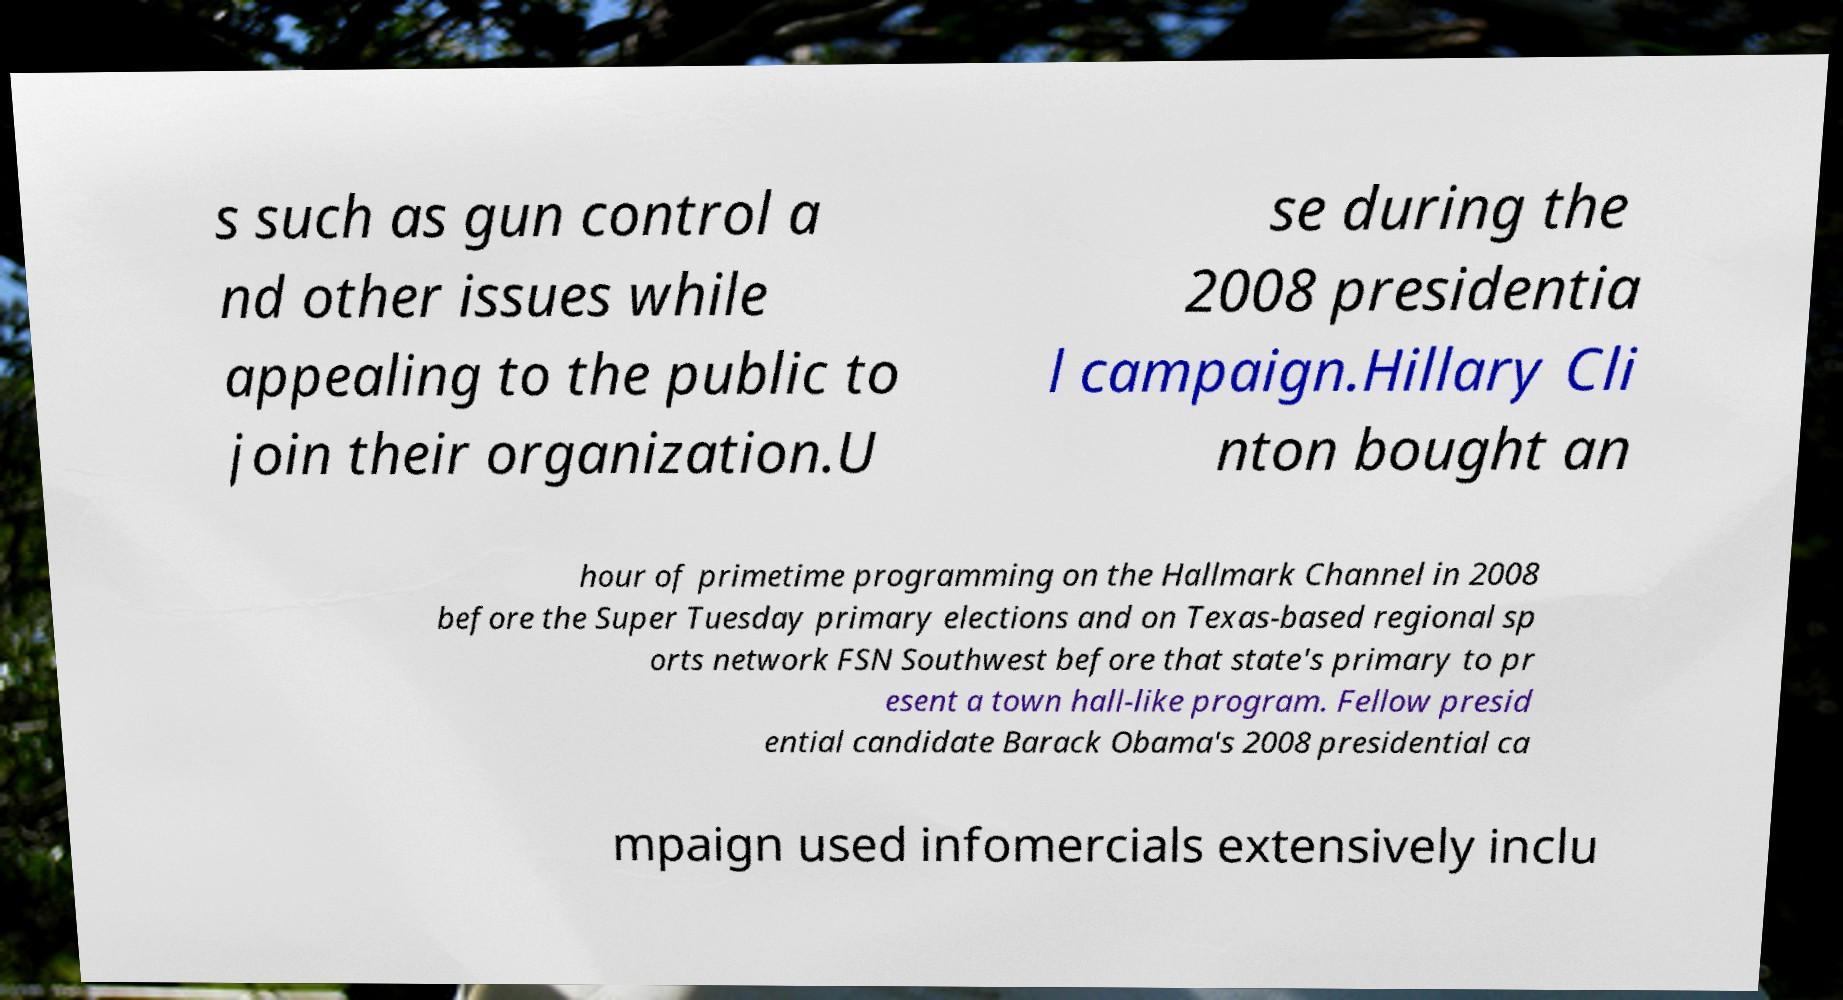Could you extract and type out the text from this image? s such as gun control a nd other issues while appealing to the public to join their organization.U se during the 2008 presidentia l campaign.Hillary Cli nton bought an hour of primetime programming on the Hallmark Channel in 2008 before the Super Tuesday primary elections and on Texas-based regional sp orts network FSN Southwest before that state's primary to pr esent a town hall-like program. Fellow presid ential candidate Barack Obama's 2008 presidential ca mpaign used infomercials extensively inclu 